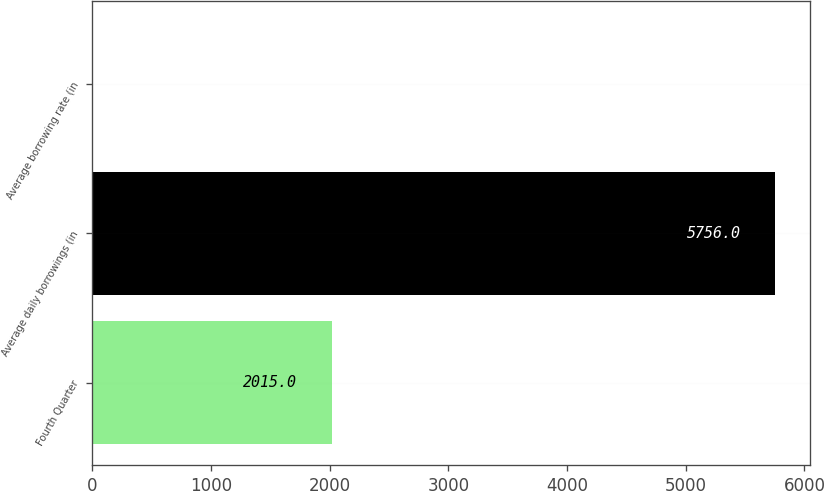Convert chart. <chart><loc_0><loc_0><loc_500><loc_500><bar_chart><fcel>Fourth Quarter<fcel>Average daily borrowings (in<fcel>Average borrowing rate (in<nl><fcel>2015<fcel>5756<fcel>6.8<nl></chart> 